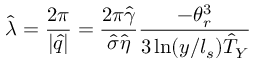Convert formula to latex. <formula><loc_0><loc_0><loc_500><loc_500>\hat { \lambda } = \frac { 2 \pi } { | \hat { q } | } = \frac { 2 \pi \hat { \gamma } } { \hat { \sigma } \hat { \eta } } \frac { - \theta _ { r } ^ { 3 } } { 3 \ln ( y / l _ { s } ) \hat { T } _ { Y } }</formula> 